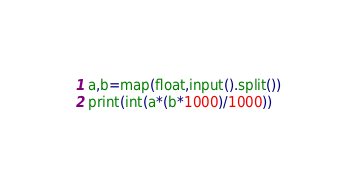<code> <loc_0><loc_0><loc_500><loc_500><_Python_>a,b=map(float,input().split())
print(int(a*(b*1000)/1000))</code> 